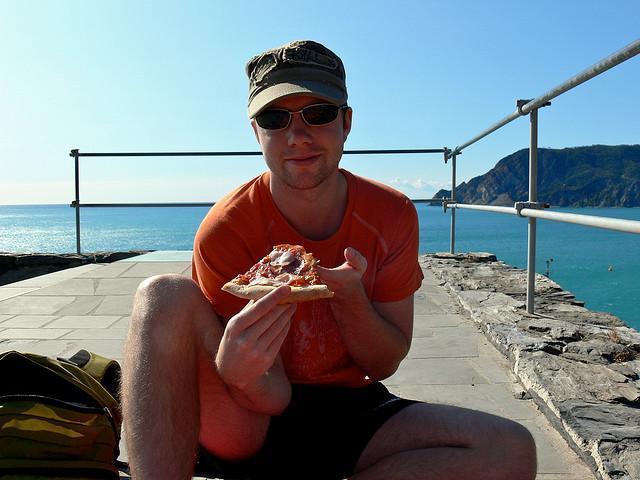How many dogs are there with brown color?
Give a very brief answer. 0. 